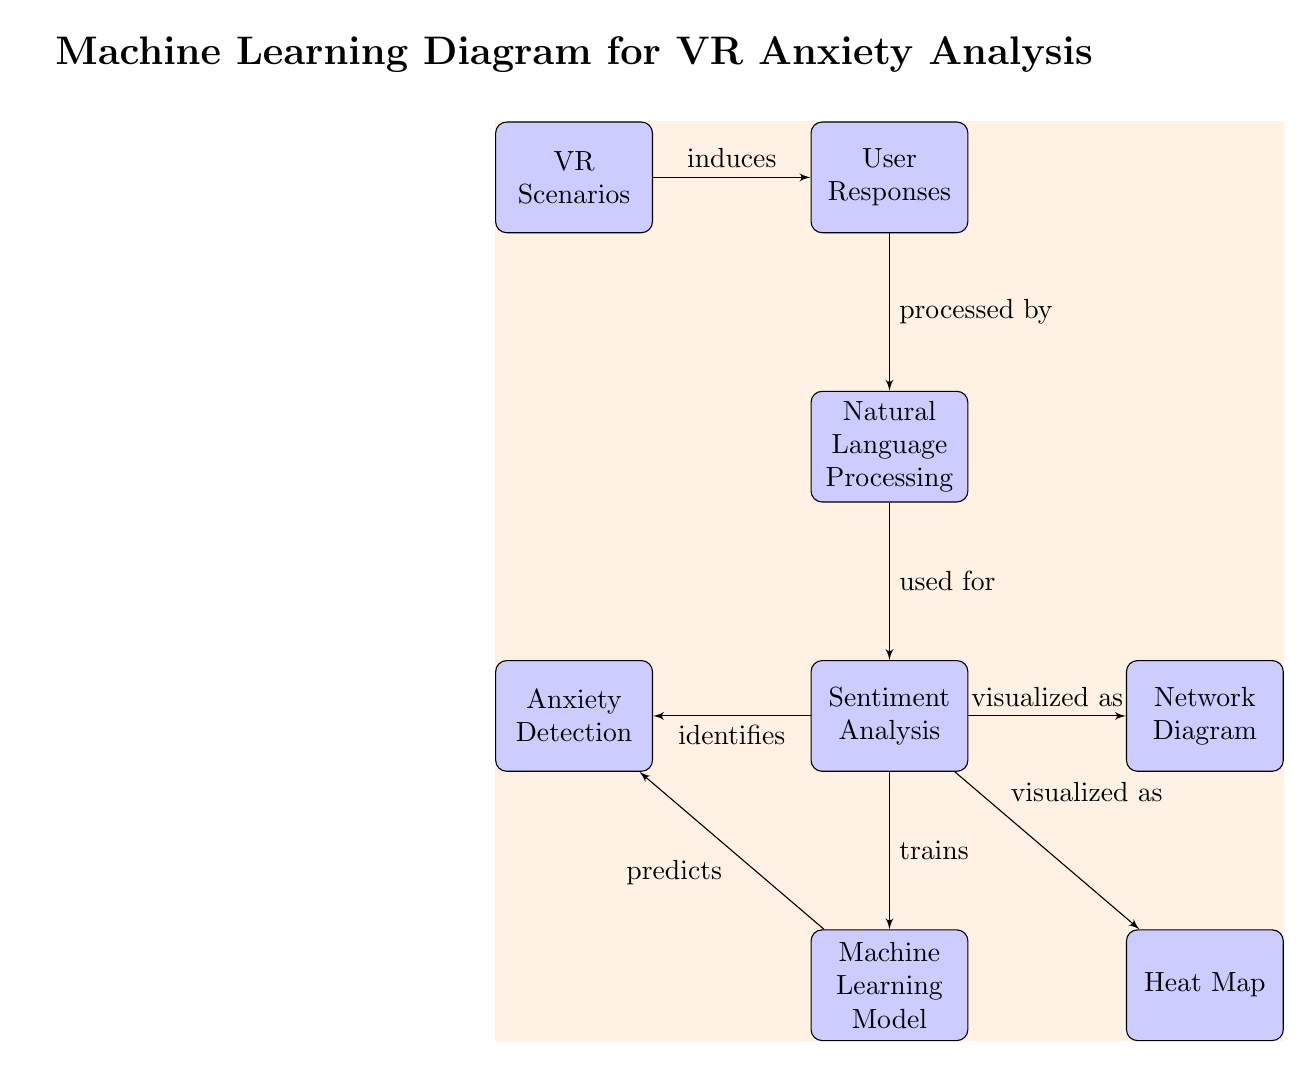What are the three main components that the user responses are processed by? The user responses are processed by Natural Language Processing, followed by Sentiment Analysis and lastly, Machine Learning Model
Answer: Natural Language Processing, Sentiment Analysis, Machine Learning Model Which node directly identifies anxiety? The node that directly identifies anxiety is Sentiment Analysis, as it indicates the output related to anxiety detection
Answer: Sentiment Analysis How many connections are there in total in the diagram? By counting the directed edges from one block to another, there are six connections in the diagram
Answer: Six What does the sentiment analysis visualize as? The sentiment analysis visualizes the results as both a Network Diagram and a Heat Map, indicating two types of visual representations
Answer: Network Diagram and Heat Map Which block is located to the right of the Sentiment Analysis block? The block located to the right of the Sentiment Analysis block is the Network Diagram, as indicated in the diagram layout
Answer: Network Diagram What component is used to train the Machine Learning Model? The component that is used to train the Machine Learning Model is the Sentiment Analysis, as shown by the directed edge from Sentiment Analysis to Machine Learning Model
Answer: Sentiment Analysis Which block is directly connected to the User Responses block? The block that is directly connected to the User Responses block is Natural Language Processing, which processes the user responses
Answer: Natural Language Processing What shape are the nodes in the diagram? The shape of the nodes in the diagram is rectangular, designed with rounded corners and filled with blue color
Answer: Rectangular 